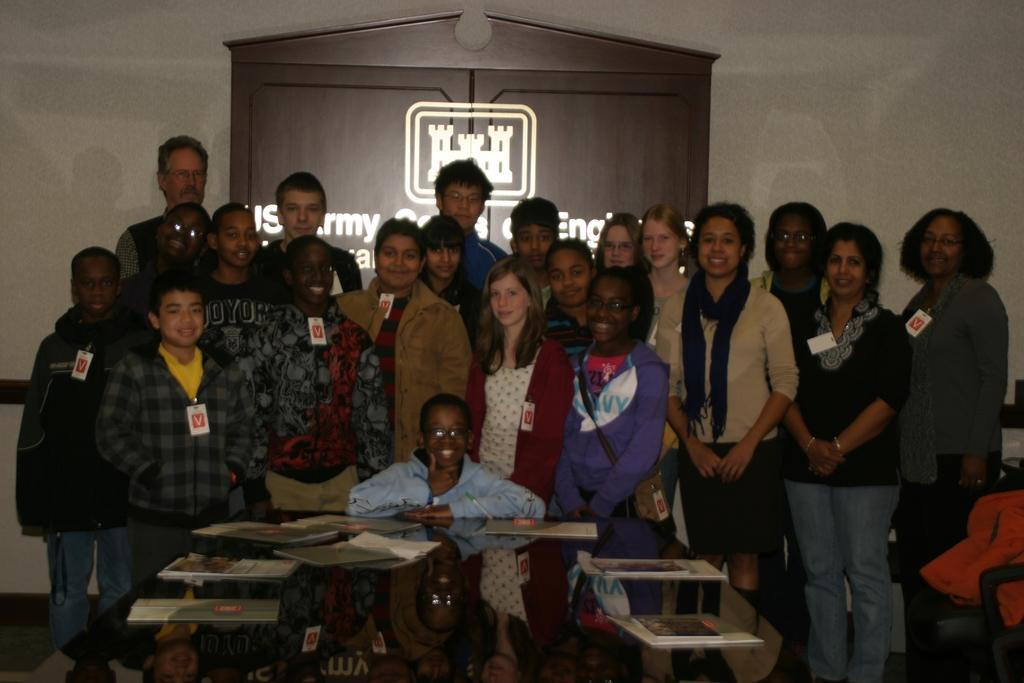What is happening in the image involving the group of people? The group of people, which includes both children and adults, is posing for a photo. What is in front of the group? There is a table in front of the group. What can be seen on the table? There are books on the table. What type of destruction can be seen happening in the image? There is no destruction present in the image; it features a group of people posing for a photo with a table and books in front of them. How many daughters are visible in the image? There is no mention of a daughter in the image, as it focuses on a group of people posing for a photo. 